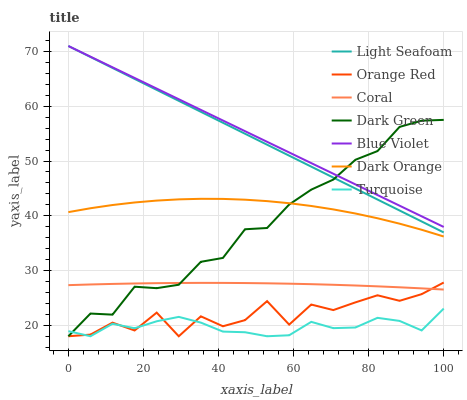Does Turquoise have the minimum area under the curve?
Answer yes or no. Yes. Does Blue Violet have the maximum area under the curve?
Answer yes or no. Yes. Does Coral have the minimum area under the curve?
Answer yes or no. No. Does Coral have the maximum area under the curve?
Answer yes or no. No. Is Light Seafoam the smoothest?
Answer yes or no. Yes. Is Orange Red the roughest?
Answer yes or no. Yes. Is Turquoise the smoothest?
Answer yes or no. No. Is Turquoise the roughest?
Answer yes or no. No. Does Coral have the lowest value?
Answer yes or no. No. Does Blue Violet have the highest value?
Answer yes or no. Yes. Does Coral have the highest value?
Answer yes or no. No. Is Orange Red less than Dark Orange?
Answer yes or no. Yes. Is Dark Orange greater than Orange Red?
Answer yes or no. Yes. Does Coral intersect Orange Red?
Answer yes or no. Yes. Is Coral less than Orange Red?
Answer yes or no. No. Is Coral greater than Orange Red?
Answer yes or no. No. Does Orange Red intersect Dark Orange?
Answer yes or no. No. 